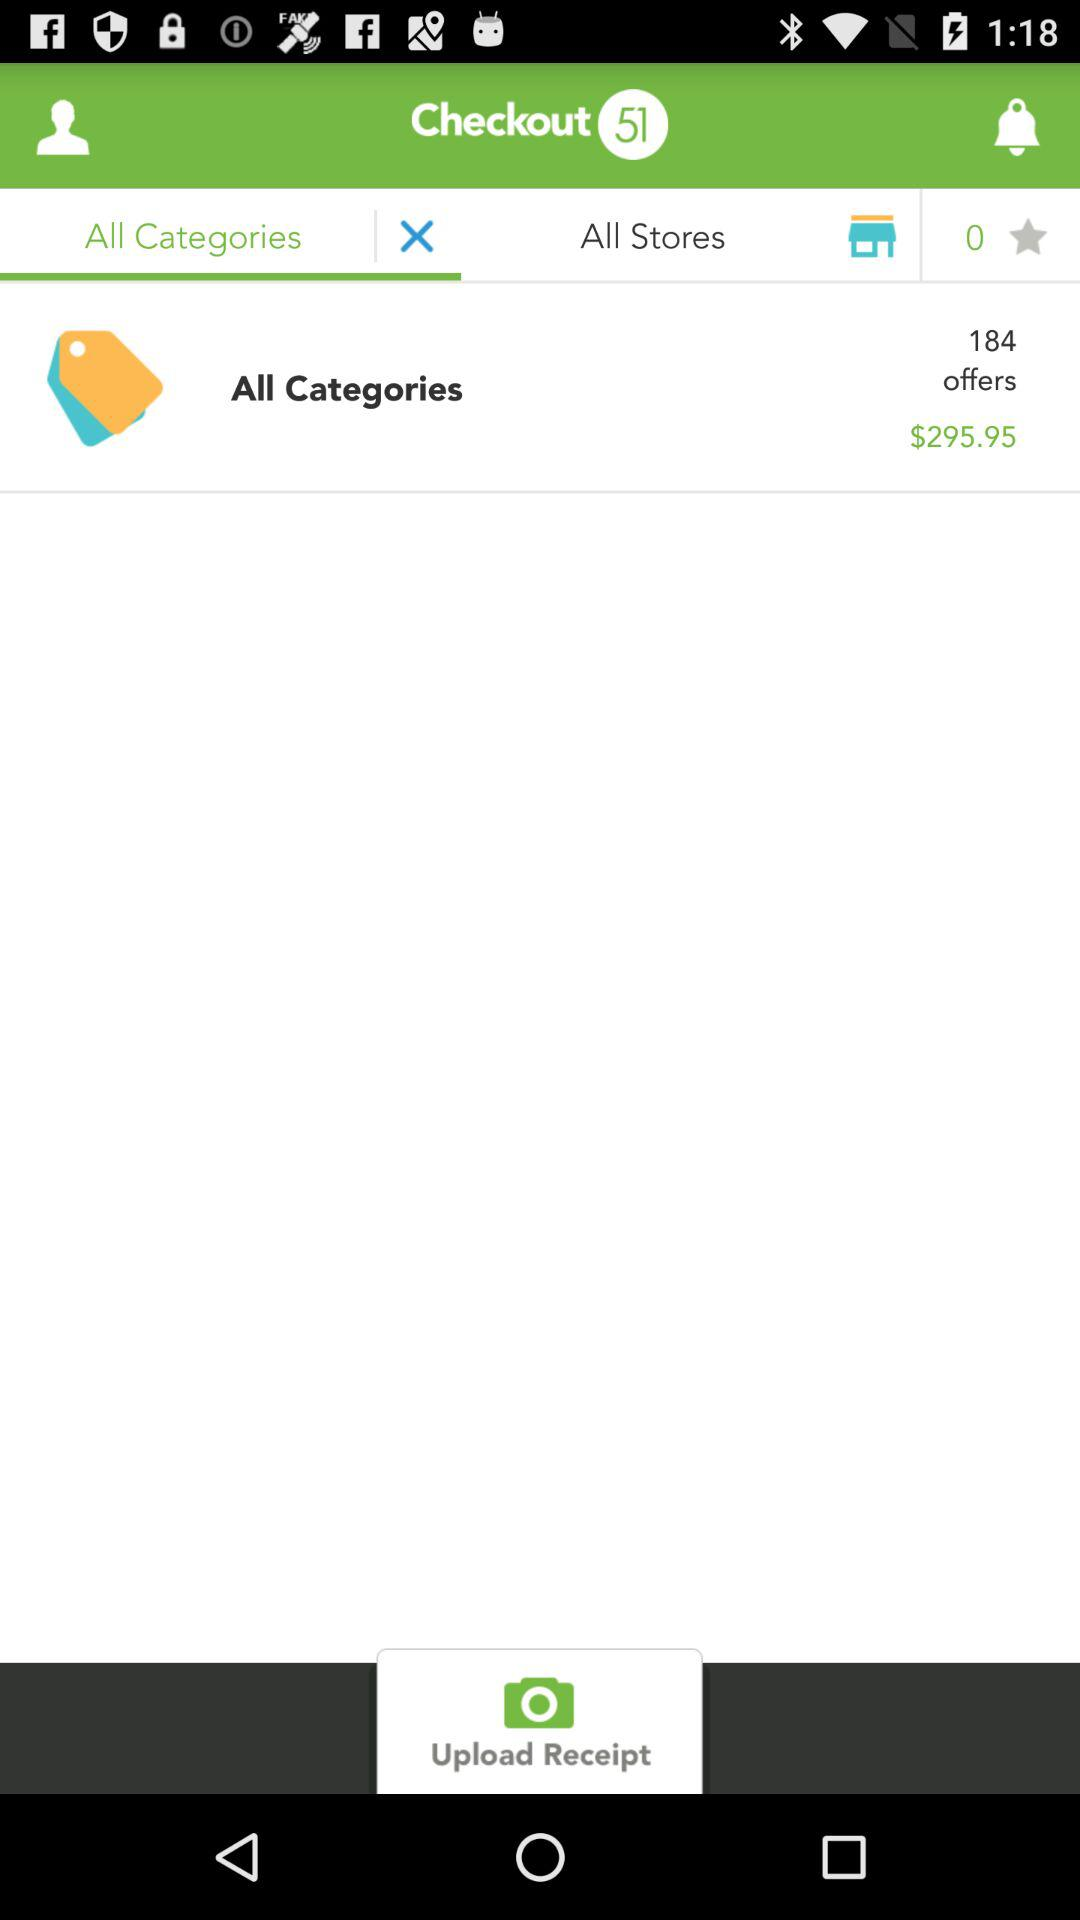How much is the total price of the order?
Answer the question using a single word or phrase. $295.95 